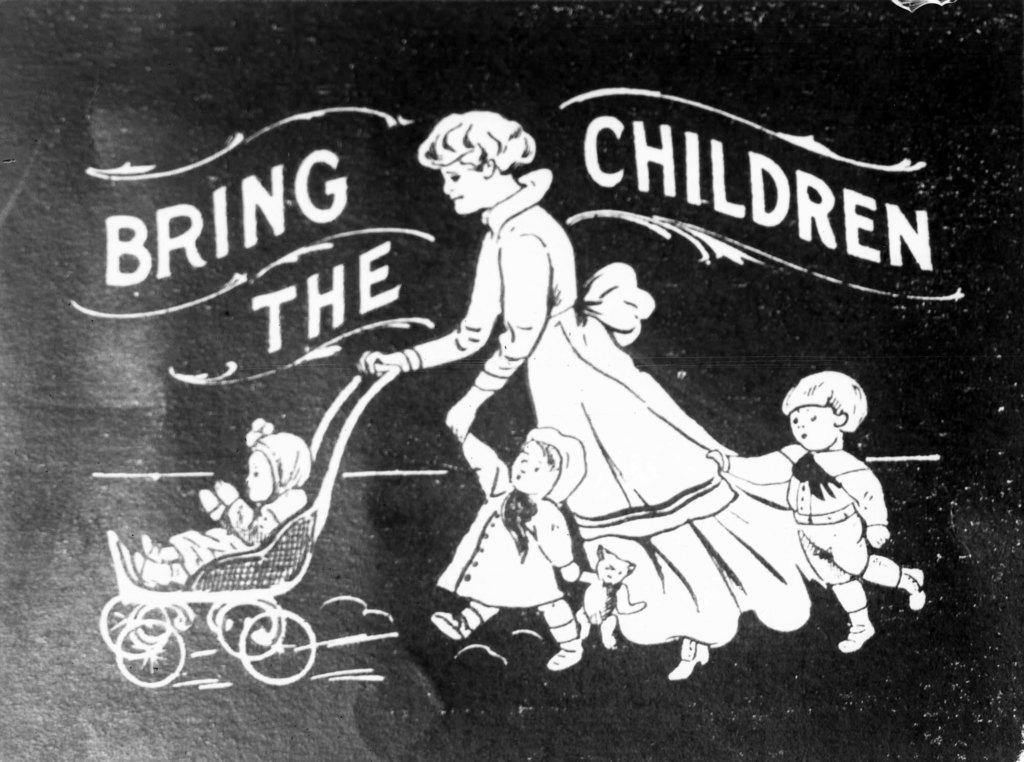What is depicted in the painting in the image? There is a painting of a woman and children in the image. What are the woman and children wearing in the painting? The woman and children are wearing clothes in the painting. What object is present in the image besides the painting? There is a baby cart in the image. What can be found in the image besides the painting and the baby cart? There is a text in the image. How many tigers are present in the image? There are no tigers present in the image. What type of event is taking place in the image? There is no event depicted in the image; it features a painting of a woman and children. 